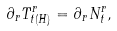Convert formula to latex. <formula><loc_0><loc_0><loc_500><loc_500>\partial _ { r } T ^ { r } _ { t ( H ) } = \partial _ { r } N ^ { r } _ { t } ,</formula> 